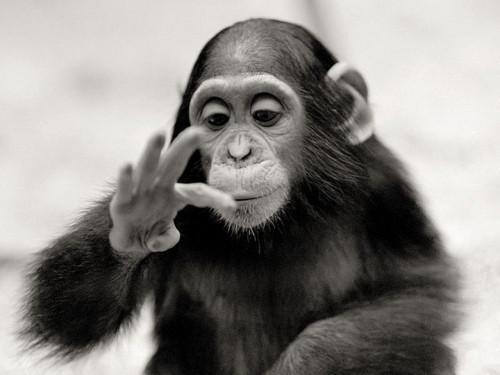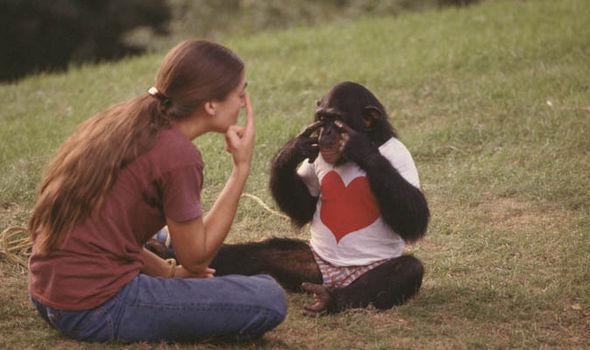The first image is the image on the left, the second image is the image on the right. Considering the images on both sides, is "The young woman is pointing towards her eye, teaching sign language to a chimp with a heart on it's white shirt." valid? Answer yes or no. Yes. The first image is the image on the left, the second image is the image on the right. Examine the images to the left and right. Is the description "There is a color photograph of a woman signing to a chimpanzee." accurate? Answer yes or no. Yes. 